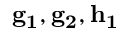Convert formula to latex. <formula><loc_0><loc_0><loc_500><loc_500>g _ { 1 } , g _ { 2 } , h _ { 1 }</formula> 